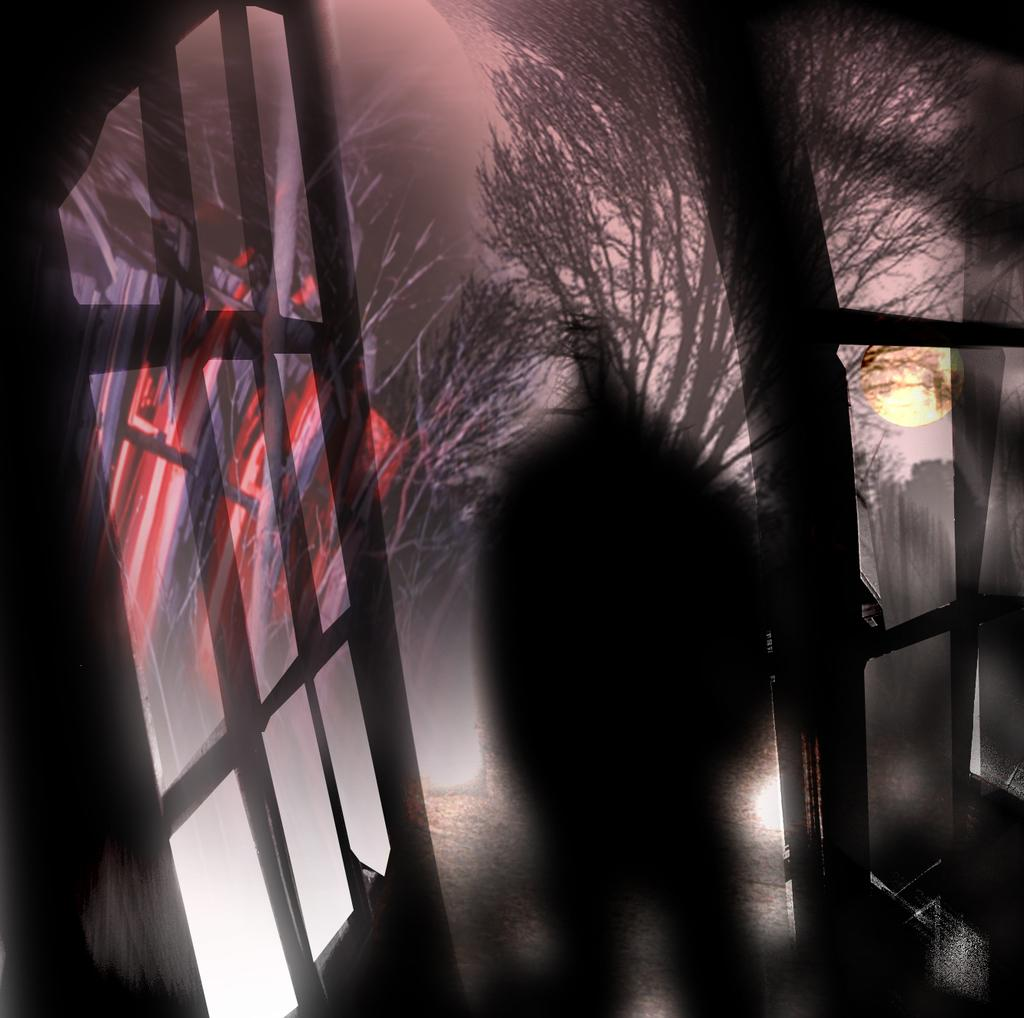What type of artwork is depicted in the image? The image is a painting. What architectural features can be seen in the painting? There are doors in the painting. What celestial body is depicted in the painting? The sun is depicted in the painting. What visual effect can be observed in the painting? There are shadows in the painting. What type of vegetation is present in the painting? Trees are present in the painting. What type of beef is being served in the painting? There is no beef present in the painting; it features a landscape with doors, the sun, shadows, and trees. What language is spoken by the trees in the painting? Trees do not speak any language, so this question cannot be answered. 